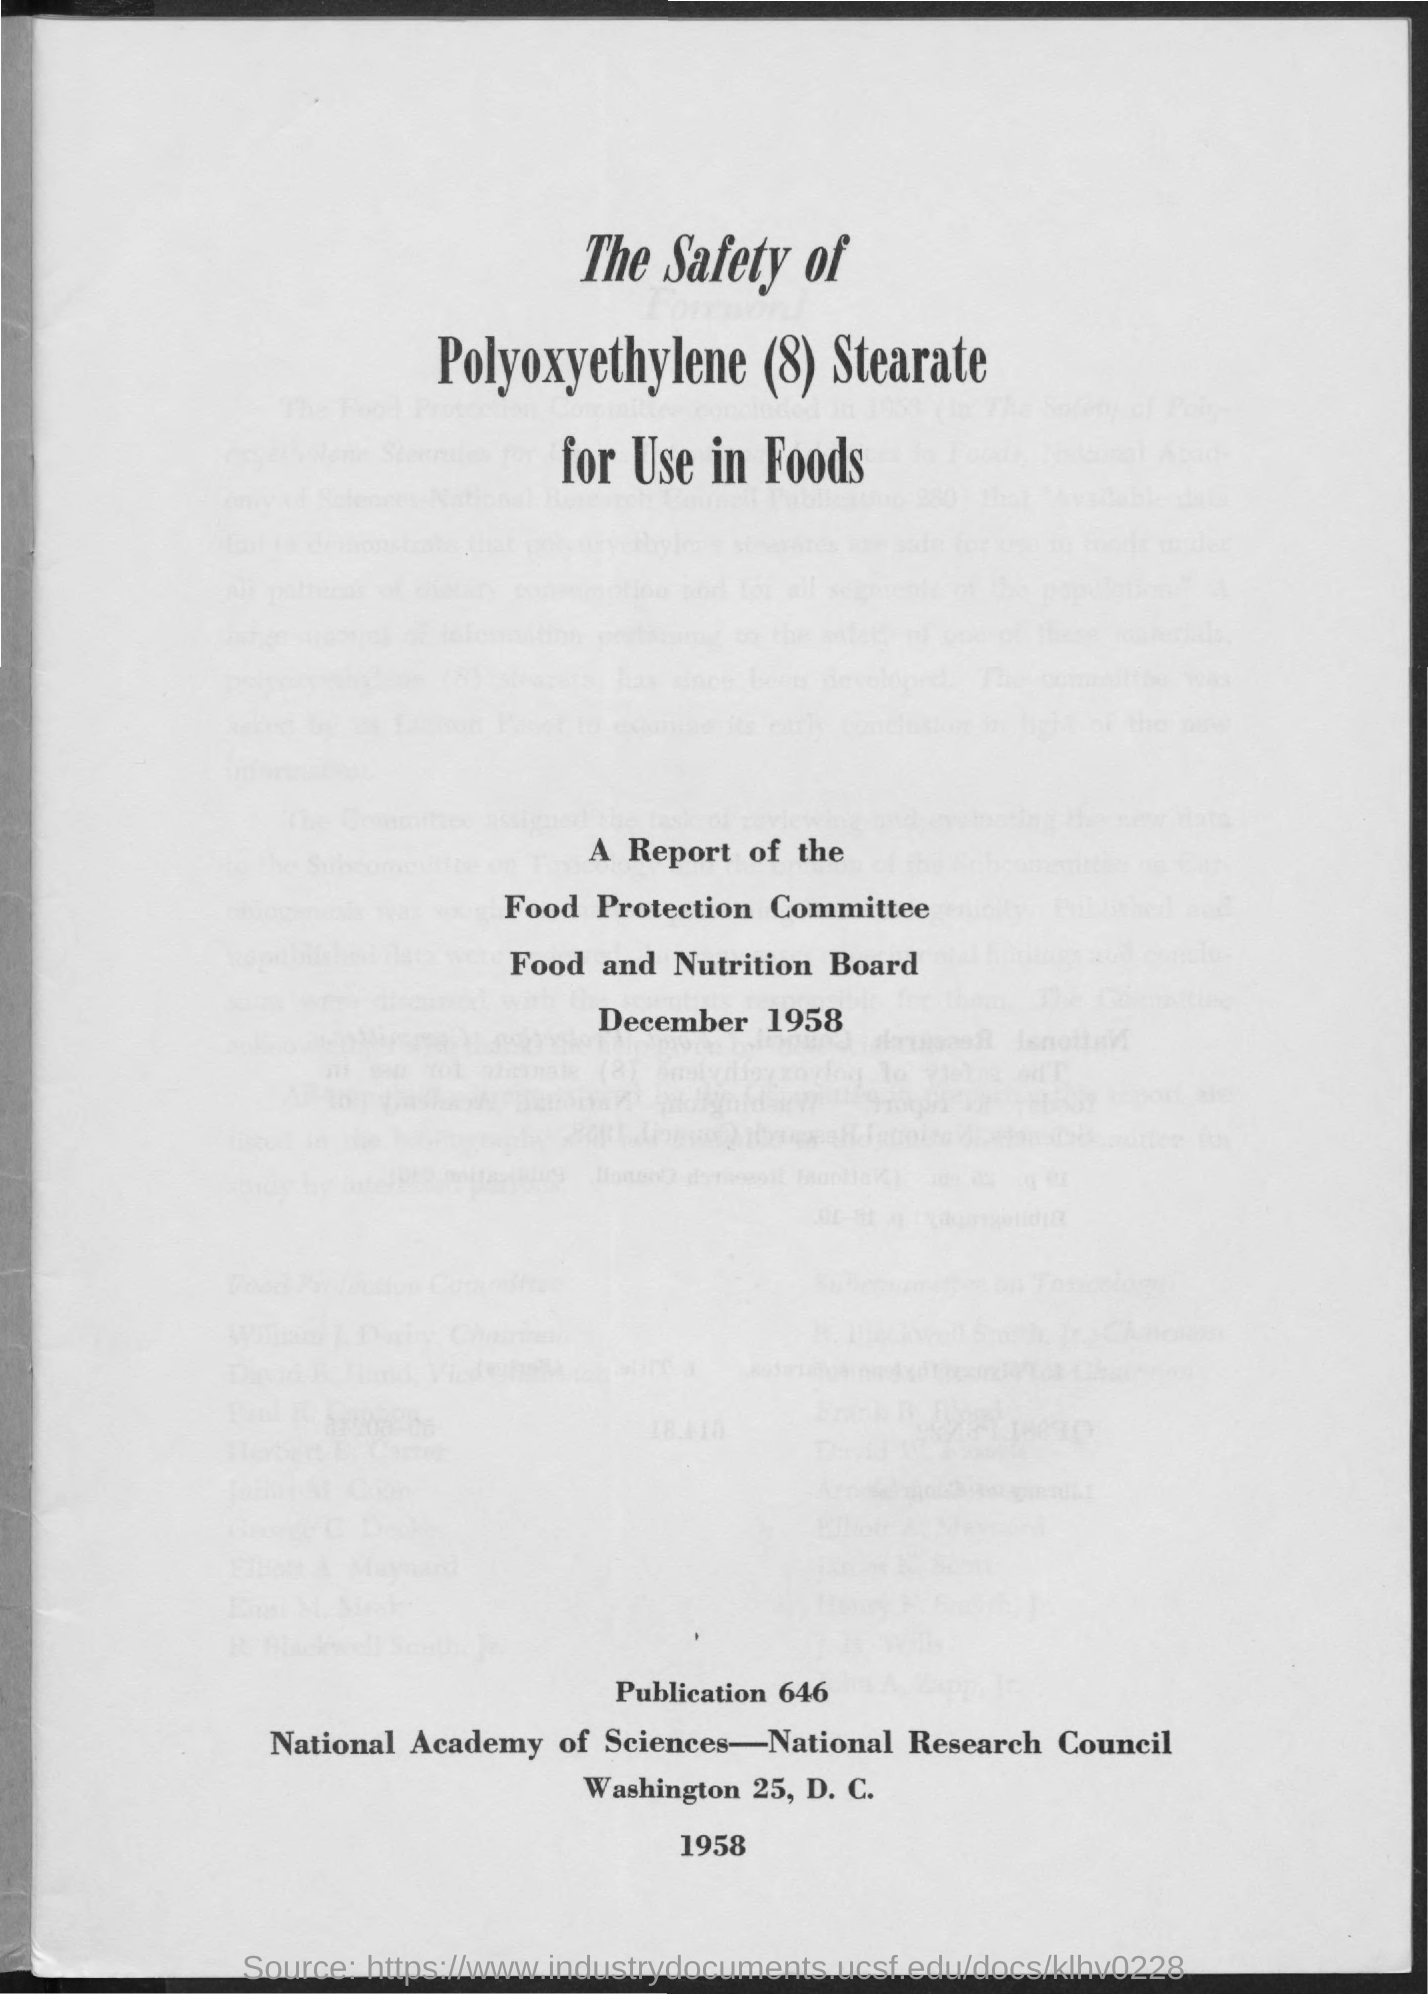What is the title of the report?
Offer a terse response. The Safety of Polyoxyethylene (8) Stearate for Use in Foods. When is the report dated?
Give a very brief answer. December 1958. What is the publication number?
Provide a short and direct response. 646. 